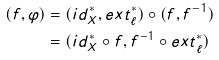<formula> <loc_0><loc_0><loc_500><loc_500>( f , \varphi ) & = ( i d ^ { * } _ { X } , e x t ^ { * } _ { \ell } ) \circ ( f , f ^ { - 1 } ) \\ & = ( i d ^ { * } _ { X } \circ f , f ^ { - 1 } \circ e x t ^ { * } _ { \ell } )</formula> 